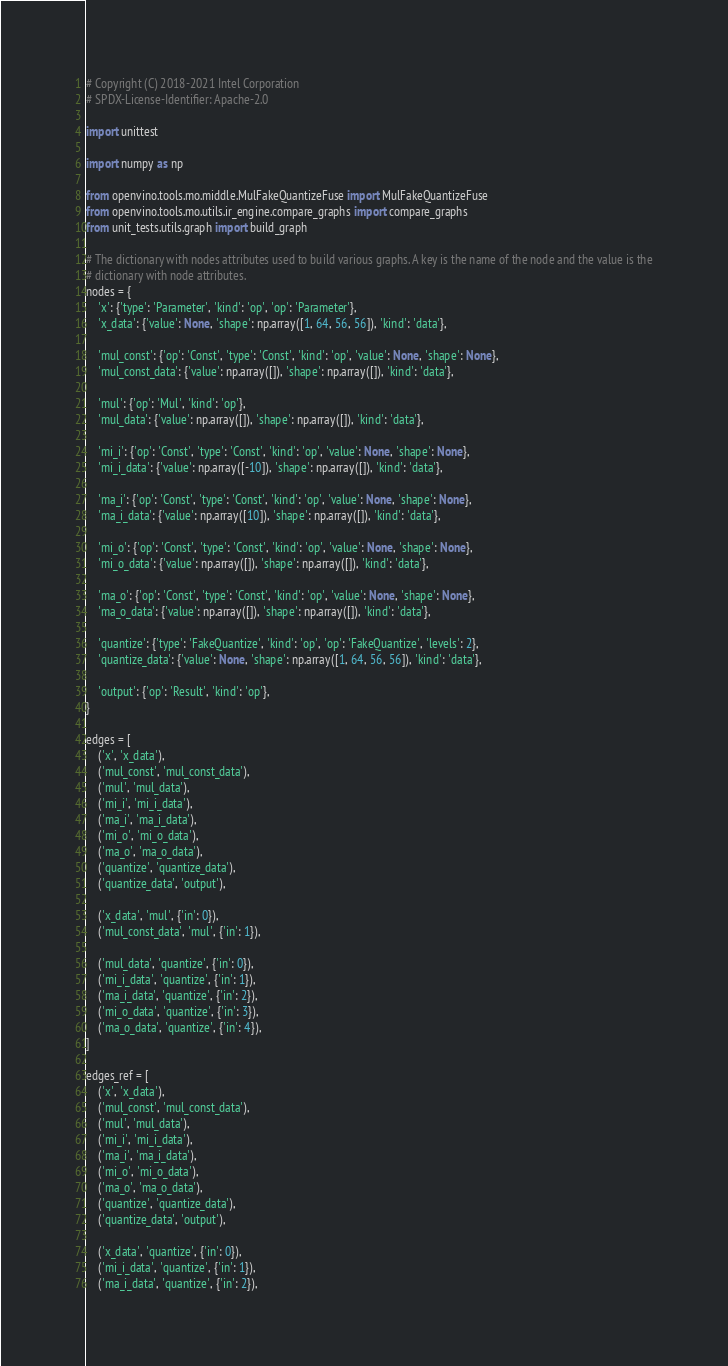Convert code to text. <code><loc_0><loc_0><loc_500><loc_500><_Python_># Copyright (C) 2018-2021 Intel Corporation
# SPDX-License-Identifier: Apache-2.0

import unittest

import numpy as np

from openvino.tools.mo.middle.MulFakeQuantizeFuse import MulFakeQuantizeFuse
from openvino.tools.mo.utils.ir_engine.compare_graphs import compare_graphs
from unit_tests.utils.graph import build_graph

# The dictionary with nodes attributes used to build various graphs. A key is the name of the node and the value is the
# dictionary with node attributes.
nodes = {
    'x': {'type': 'Parameter', 'kind': 'op', 'op': 'Parameter'},
    'x_data': {'value': None, 'shape': np.array([1, 64, 56, 56]), 'kind': 'data'},

    'mul_const': {'op': 'Const', 'type': 'Const', 'kind': 'op', 'value': None, 'shape': None},
    'mul_const_data': {'value': np.array([]), 'shape': np.array([]), 'kind': 'data'},

    'mul': {'op': 'Mul', 'kind': 'op'},
    'mul_data': {'value': np.array([]), 'shape': np.array([]), 'kind': 'data'},

    'mi_i': {'op': 'Const', 'type': 'Const', 'kind': 'op', 'value': None, 'shape': None},
    'mi_i_data': {'value': np.array([-10]), 'shape': np.array([]), 'kind': 'data'},

    'ma_i': {'op': 'Const', 'type': 'Const', 'kind': 'op', 'value': None, 'shape': None},
    'ma_i_data': {'value': np.array([10]), 'shape': np.array([]), 'kind': 'data'},

    'mi_o': {'op': 'Const', 'type': 'Const', 'kind': 'op', 'value': None, 'shape': None},
    'mi_o_data': {'value': np.array([]), 'shape': np.array([]), 'kind': 'data'},

    'ma_o': {'op': 'Const', 'type': 'Const', 'kind': 'op', 'value': None, 'shape': None},
    'ma_o_data': {'value': np.array([]), 'shape': np.array([]), 'kind': 'data'},

    'quantize': {'type': 'FakeQuantize', 'kind': 'op', 'op': 'FakeQuantize', 'levels': 2},
    'quantize_data': {'value': None, 'shape': np.array([1, 64, 56, 56]), 'kind': 'data'},

    'output': {'op': 'Result', 'kind': 'op'},
}

edges = [
    ('x', 'x_data'),
    ('mul_const', 'mul_const_data'),
    ('mul', 'mul_data'),
    ('mi_i', 'mi_i_data'),
    ('ma_i', 'ma_i_data'),
    ('mi_o', 'mi_o_data'),
    ('ma_o', 'ma_o_data'),
    ('quantize', 'quantize_data'),
    ('quantize_data', 'output'),

    ('x_data', 'mul', {'in': 0}),
    ('mul_const_data', 'mul', {'in': 1}),

    ('mul_data', 'quantize', {'in': 0}),
    ('mi_i_data', 'quantize', {'in': 1}),
    ('ma_i_data', 'quantize', {'in': 2}),
    ('mi_o_data', 'quantize', {'in': 3}),
    ('ma_o_data', 'quantize', {'in': 4}),
]

edges_ref = [
    ('x', 'x_data'),
    ('mul_const', 'mul_const_data'),
    ('mul', 'mul_data'),
    ('mi_i', 'mi_i_data'),
    ('ma_i', 'ma_i_data'),
    ('mi_o', 'mi_o_data'),
    ('ma_o', 'ma_o_data'),
    ('quantize', 'quantize_data'),
    ('quantize_data', 'output'),

    ('x_data', 'quantize', {'in': 0}),
    ('mi_i_data', 'quantize', {'in': 1}),
    ('ma_i_data', 'quantize', {'in': 2}),</code> 